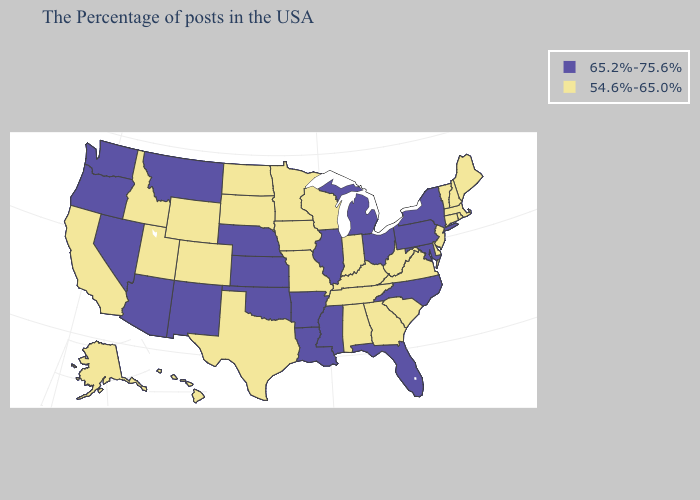What is the lowest value in the Northeast?
Short answer required. 54.6%-65.0%. Does the map have missing data?
Be succinct. No. Name the states that have a value in the range 65.2%-75.6%?
Be succinct. New York, Maryland, Pennsylvania, North Carolina, Ohio, Florida, Michigan, Illinois, Mississippi, Louisiana, Arkansas, Kansas, Nebraska, Oklahoma, New Mexico, Montana, Arizona, Nevada, Washington, Oregon. Name the states that have a value in the range 54.6%-65.0%?
Write a very short answer. Maine, Massachusetts, Rhode Island, New Hampshire, Vermont, Connecticut, New Jersey, Delaware, Virginia, South Carolina, West Virginia, Georgia, Kentucky, Indiana, Alabama, Tennessee, Wisconsin, Missouri, Minnesota, Iowa, Texas, South Dakota, North Dakota, Wyoming, Colorado, Utah, Idaho, California, Alaska, Hawaii. Name the states that have a value in the range 65.2%-75.6%?
Be succinct. New York, Maryland, Pennsylvania, North Carolina, Ohio, Florida, Michigan, Illinois, Mississippi, Louisiana, Arkansas, Kansas, Nebraska, Oklahoma, New Mexico, Montana, Arizona, Nevada, Washington, Oregon. Name the states that have a value in the range 65.2%-75.6%?
Answer briefly. New York, Maryland, Pennsylvania, North Carolina, Ohio, Florida, Michigan, Illinois, Mississippi, Louisiana, Arkansas, Kansas, Nebraska, Oklahoma, New Mexico, Montana, Arizona, Nevada, Washington, Oregon. What is the value of Indiana?
Answer briefly. 54.6%-65.0%. What is the value of Hawaii?
Short answer required. 54.6%-65.0%. Does Texas have the same value as Massachusetts?
Keep it brief. Yes. What is the highest value in the USA?
Keep it brief. 65.2%-75.6%. Does Kentucky have a higher value than South Carolina?
Concise answer only. No. What is the value of Pennsylvania?
Keep it brief. 65.2%-75.6%. Name the states that have a value in the range 54.6%-65.0%?
Be succinct. Maine, Massachusetts, Rhode Island, New Hampshire, Vermont, Connecticut, New Jersey, Delaware, Virginia, South Carolina, West Virginia, Georgia, Kentucky, Indiana, Alabama, Tennessee, Wisconsin, Missouri, Minnesota, Iowa, Texas, South Dakota, North Dakota, Wyoming, Colorado, Utah, Idaho, California, Alaska, Hawaii. Does Hawaii have the highest value in the West?
Give a very brief answer. No. Name the states that have a value in the range 54.6%-65.0%?
Short answer required. Maine, Massachusetts, Rhode Island, New Hampshire, Vermont, Connecticut, New Jersey, Delaware, Virginia, South Carolina, West Virginia, Georgia, Kentucky, Indiana, Alabama, Tennessee, Wisconsin, Missouri, Minnesota, Iowa, Texas, South Dakota, North Dakota, Wyoming, Colorado, Utah, Idaho, California, Alaska, Hawaii. 